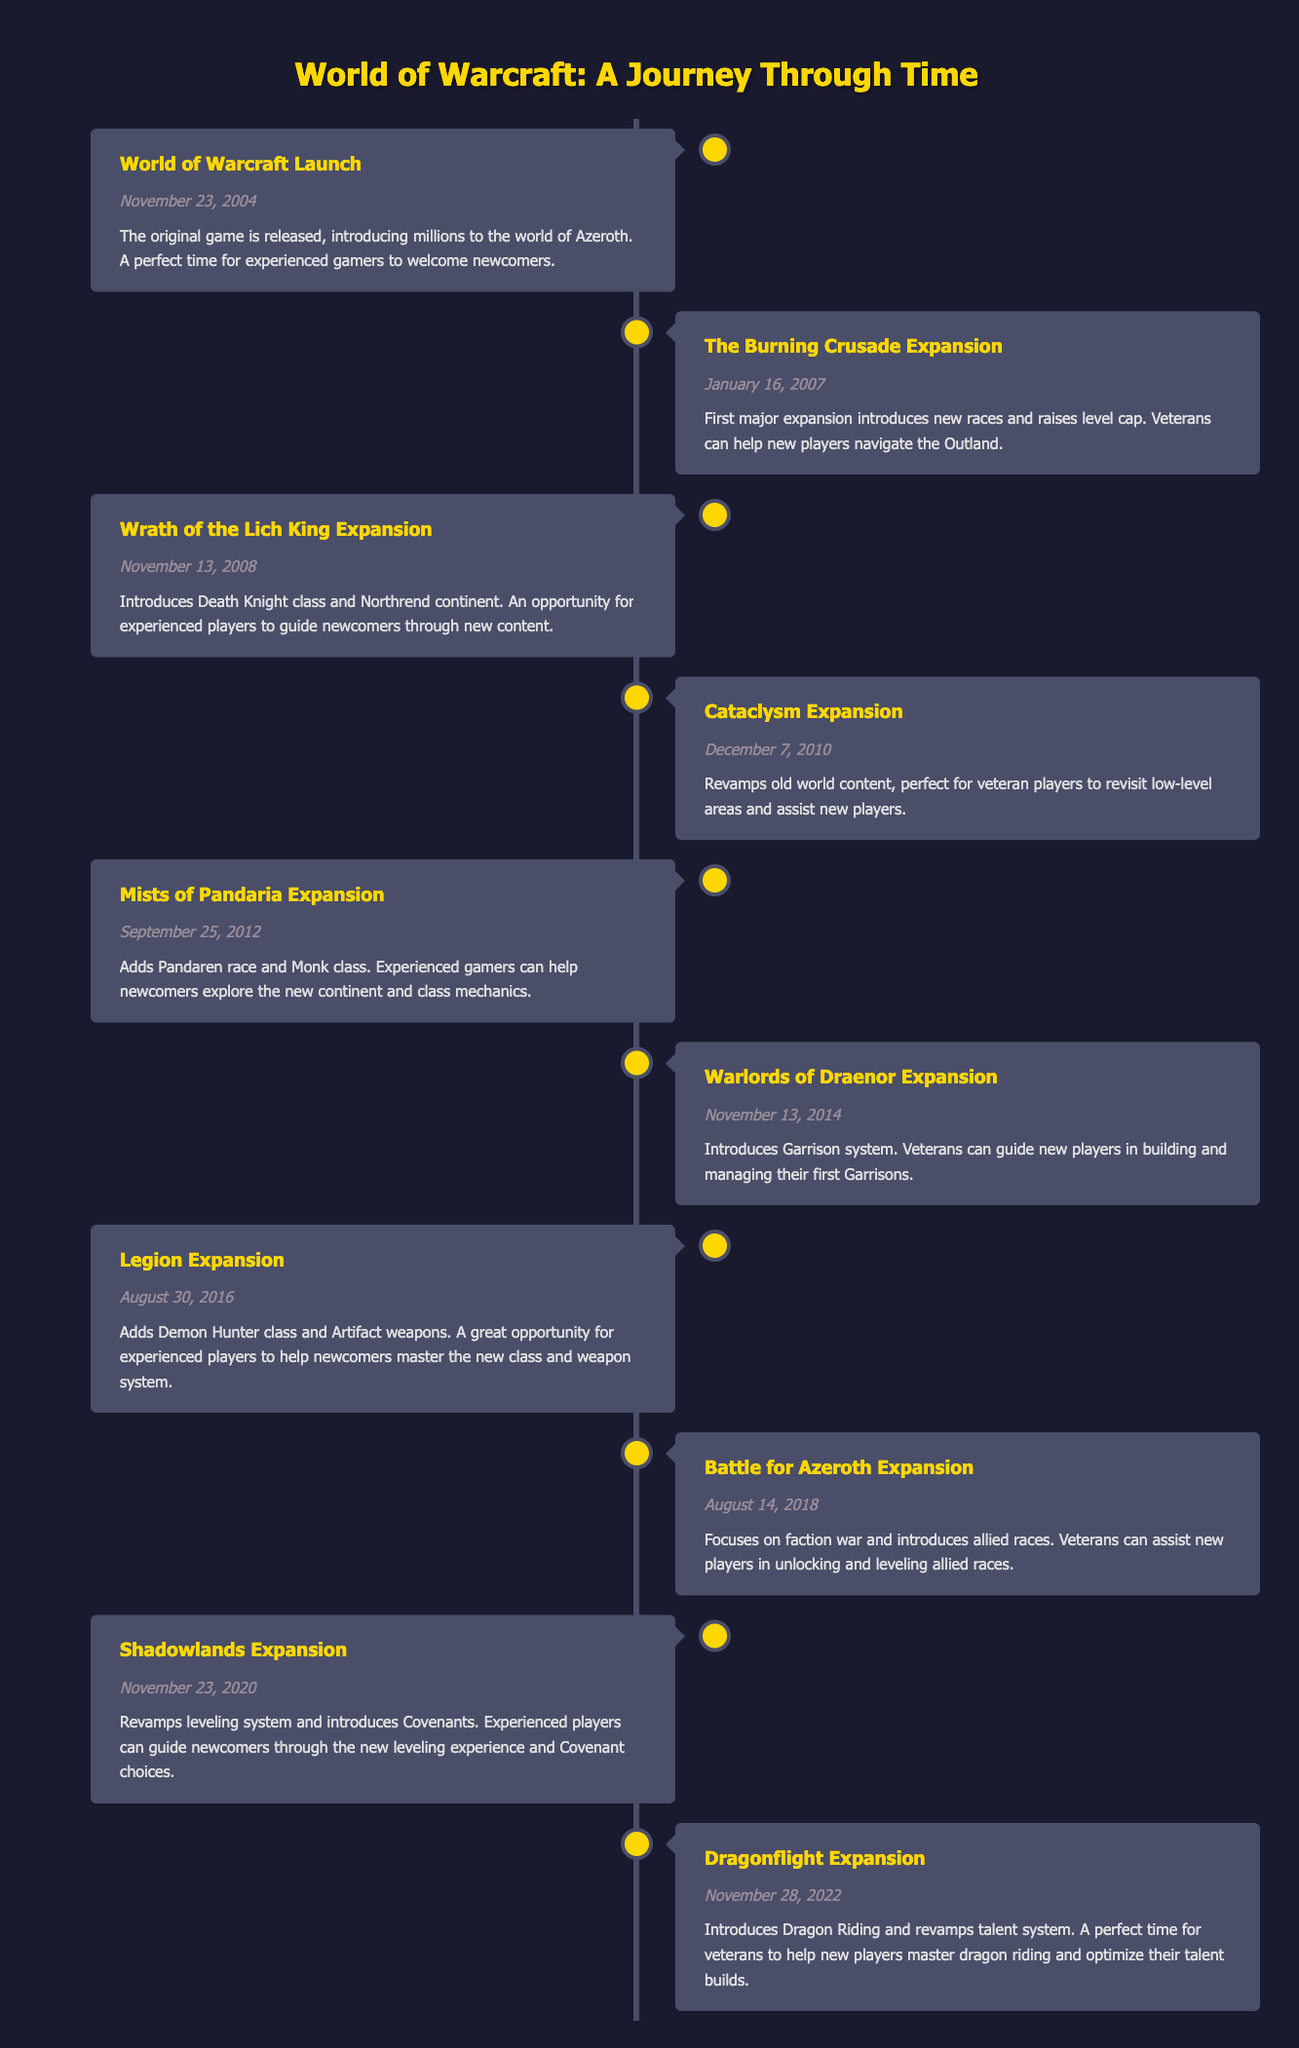What date did the "Dragonflight Expansion" occur? The timeline indicates that the "Dragonflight Expansion" event is listed under the date "November 28, 2022." Therefore, the date of this expansion is directly retrievable from the table.
Answer: November 28, 2022 Which expansion introduced the "Demon Hunter" class? The table notes that the "Legion Expansion," which occurred on "August 30, 2016," introduced the Demon Hunter class. This detail can be identified by examining the events listed.
Answer: Legion Expansion How many expansions were released between 2004 and 2016? By reviewing the timeline, the expansions during this period are: "The Burning Crusade," "Wrath of the Lich King," "Cataclysm," "Mists of Pandaria," and "Legion," totaling five expansions released.
Answer: 5 Did the "Shadowlands Expansion" revamp the leveling system? According to the event description of the "Shadowlands Expansion," it states that it revamps the leveling system, confirming that the statement is true.
Answer: Yes Which expansion comes immediately after "Warlords of Draenor"? The timeline shows that "Legion Expansion" follows "Warlords of Draenor," released on "November 13, 2014," and then "Legion" was released on "August 30, 2016." Therefore, the expansion that comes immediately after is "Legion Expansion."
Answer: Legion Expansion What is the primary focus of the "Battle for Azeroth Expansion"? The description for the "Battle for Azeroth Expansion" clearly mentions that its focus is on the faction war. Therefore, the answer is directly taken from the documentation provided in the table for this event.
Answer: Faction war How many years passed between the launch of "World of Warcraft" and the "Cataclysm Expansion"? The launch date of "World of Warcraft" is "November 23, 2004," and the "Cataclysm Expansion" was released on "December 7, 2010." The time difference is about six years (from late 2004 to late 2010).
Answer: 6 years Which expansions introduced new races? Examining the table, two expansions introduce new races: "The Burning Crusade" (new races) and "Mists of Pandaria" (Pandaren race). Thus, we pull out these two events to arrive at the answer to the question.
Answer: The Burning Crusade, Mists of Pandaria What is the earliest expansion that revamped old world content? The table lists the "Cataclysm Expansion" on "December 7, 2010," and specifically mentions that it revamps old world content, showing this is the earliest expansion that does so.
Answer: Cataclysm Expansion 